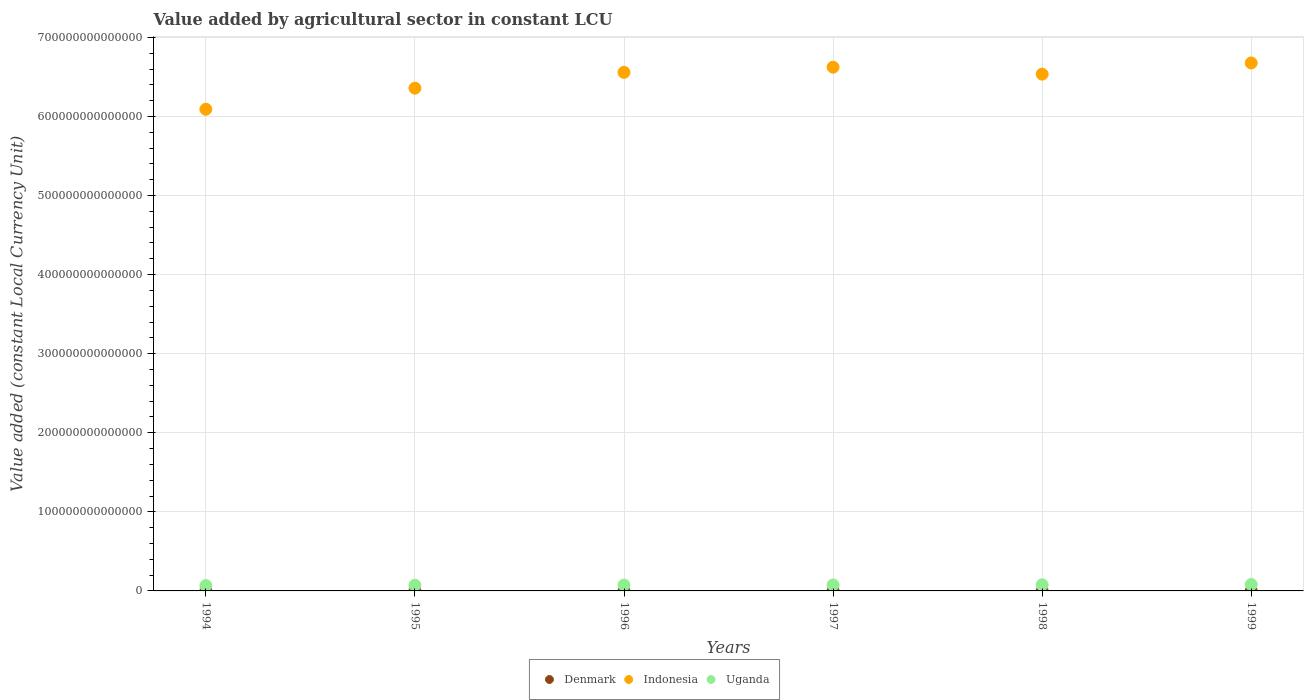How many different coloured dotlines are there?
Keep it short and to the point. 3. Is the number of dotlines equal to the number of legend labels?
Make the answer very short. Yes. What is the value added by agricultural sector in Denmark in 1997?
Give a very brief answer. 2.01e+1. Across all years, what is the maximum value added by agricultural sector in Indonesia?
Your answer should be very brief. 6.68e+14. Across all years, what is the minimum value added by agricultural sector in Uganda?
Provide a succinct answer. 6.78e+12. In which year was the value added by agricultural sector in Denmark maximum?
Offer a terse response. 1998. What is the total value added by agricultural sector in Indonesia in the graph?
Keep it short and to the point. 3.88e+15. What is the difference between the value added by agricultural sector in Uganda in 1997 and that in 1999?
Offer a terse response. -5.82e+11. What is the difference between the value added by agricultural sector in Uganda in 1995 and the value added by agricultural sector in Indonesia in 1999?
Your response must be concise. -6.60e+14. What is the average value added by agricultural sector in Indonesia per year?
Your answer should be very brief. 6.47e+14. In the year 1994, what is the difference between the value added by agricultural sector in Indonesia and value added by agricultural sector in Denmark?
Your response must be concise. 6.09e+14. What is the ratio of the value added by agricultural sector in Uganda in 1996 to that in 1997?
Keep it short and to the point. 0.99. What is the difference between the highest and the second highest value added by agricultural sector in Uganda?
Make the answer very short. 4.48e+11. What is the difference between the highest and the lowest value added by agricultural sector in Denmark?
Offer a very short reply. 2.42e+09. In how many years, is the value added by agricultural sector in Uganda greater than the average value added by agricultural sector in Uganda taken over all years?
Your answer should be very brief. 4. Is the sum of the value added by agricultural sector in Denmark in 1997 and 1998 greater than the maximum value added by agricultural sector in Indonesia across all years?
Keep it short and to the point. No. Is it the case that in every year, the sum of the value added by agricultural sector in Indonesia and value added by agricultural sector in Denmark  is greater than the value added by agricultural sector in Uganda?
Your answer should be compact. Yes. Is the value added by agricultural sector in Denmark strictly greater than the value added by agricultural sector in Uganda over the years?
Your response must be concise. No. Is the value added by agricultural sector in Indonesia strictly less than the value added by agricultural sector in Denmark over the years?
Make the answer very short. No. How many years are there in the graph?
Make the answer very short. 6. What is the difference between two consecutive major ticks on the Y-axis?
Your answer should be compact. 1.00e+14. Are the values on the major ticks of Y-axis written in scientific E-notation?
Your response must be concise. No. Does the graph contain grids?
Offer a very short reply. Yes. What is the title of the graph?
Provide a succinct answer. Value added by agricultural sector in constant LCU. What is the label or title of the Y-axis?
Offer a terse response. Value added (constant Local Currency Unit). What is the Value added (constant Local Currency Unit) in Denmark in 1994?
Offer a terse response. 1.79e+1. What is the Value added (constant Local Currency Unit) of Indonesia in 1994?
Offer a terse response. 6.09e+14. What is the Value added (constant Local Currency Unit) of Uganda in 1994?
Offer a very short reply. 6.78e+12. What is the Value added (constant Local Currency Unit) of Denmark in 1995?
Offer a terse response. 1.89e+1. What is the Value added (constant Local Currency Unit) in Indonesia in 1995?
Provide a short and direct response. 6.36e+14. What is the Value added (constant Local Currency Unit) in Uganda in 1995?
Offer a terse response. 7.18e+12. What is the Value added (constant Local Currency Unit) in Denmark in 1996?
Your response must be concise. 1.94e+1. What is the Value added (constant Local Currency Unit) of Indonesia in 1996?
Your answer should be very brief. 6.56e+14. What is the Value added (constant Local Currency Unit) in Uganda in 1996?
Ensure brevity in your answer.  7.48e+12. What is the Value added (constant Local Currency Unit) of Denmark in 1997?
Your answer should be very brief. 2.01e+1. What is the Value added (constant Local Currency Unit) of Indonesia in 1997?
Provide a short and direct response. 6.62e+14. What is the Value added (constant Local Currency Unit) of Uganda in 1997?
Keep it short and to the point. 7.57e+12. What is the Value added (constant Local Currency Unit) of Denmark in 1998?
Offer a terse response. 2.04e+1. What is the Value added (constant Local Currency Unit) of Indonesia in 1998?
Offer a very short reply. 6.54e+14. What is the Value added (constant Local Currency Unit) of Uganda in 1998?
Your response must be concise. 7.70e+12. What is the Value added (constant Local Currency Unit) in Denmark in 1999?
Give a very brief answer. 2.01e+1. What is the Value added (constant Local Currency Unit) of Indonesia in 1999?
Your answer should be compact. 6.68e+14. What is the Value added (constant Local Currency Unit) in Uganda in 1999?
Offer a very short reply. 8.15e+12. Across all years, what is the maximum Value added (constant Local Currency Unit) of Denmark?
Make the answer very short. 2.04e+1. Across all years, what is the maximum Value added (constant Local Currency Unit) in Indonesia?
Your answer should be compact. 6.68e+14. Across all years, what is the maximum Value added (constant Local Currency Unit) in Uganda?
Offer a very short reply. 8.15e+12. Across all years, what is the minimum Value added (constant Local Currency Unit) of Denmark?
Ensure brevity in your answer.  1.79e+1. Across all years, what is the minimum Value added (constant Local Currency Unit) in Indonesia?
Give a very brief answer. 6.09e+14. Across all years, what is the minimum Value added (constant Local Currency Unit) of Uganda?
Offer a very short reply. 6.78e+12. What is the total Value added (constant Local Currency Unit) in Denmark in the graph?
Your response must be concise. 1.17e+11. What is the total Value added (constant Local Currency Unit) of Indonesia in the graph?
Provide a short and direct response. 3.88e+15. What is the total Value added (constant Local Currency Unit) of Uganda in the graph?
Your answer should be very brief. 4.49e+13. What is the difference between the Value added (constant Local Currency Unit) of Denmark in 1994 and that in 1995?
Your response must be concise. -9.51e+08. What is the difference between the Value added (constant Local Currency Unit) of Indonesia in 1994 and that in 1995?
Give a very brief answer. -2.67e+13. What is the difference between the Value added (constant Local Currency Unit) of Uganda in 1994 and that in 1995?
Keep it short and to the point. -4.00e+11. What is the difference between the Value added (constant Local Currency Unit) in Denmark in 1994 and that in 1996?
Provide a short and direct response. -1.47e+09. What is the difference between the Value added (constant Local Currency Unit) of Indonesia in 1994 and that in 1996?
Your response must be concise. -4.66e+13. What is the difference between the Value added (constant Local Currency Unit) of Uganda in 1994 and that in 1996?
Provide a succinct answer. -7.05e+11. What is the difference between the Value added (constant Local Currency Unit) of Denmark in 1994 and that in 1997?
Offer a terse response. -2.12e+09. What is the difference between the Value added (constant Local Currency Unit) of Indonesia in 1994 and that in 1997?
Give a very brief answer. -5.32e+13. What is the difference between the Value added (constant Local Currency Unit) of Uganda in 1994 and that in 1997?
Provide a succinct answer. -7.87e+11. What is the difference between the Value added (constant Local Currency Unit) of Denmark in 1994 and that in 1998?
Provide a succinct answer. -2.42e+09. What is the difference between the Value added (constant Local Currency Unit) in Indonesia in 1994 and that in 1998?
Provide a short and direct response. -4.44e+13. What is the difference between the Value added (constant Local Currency Unit) of Uganda in 1994 and that in 1998?
Your response must be concise. -9.21e+11. What is the difference between the Value added (constant Local Currency Unit) of Denmark in 1994 and that in 1999?
Offer a terse response. -2.17e+09. What is the difference between the Value added (constant Local Currency Unit) in Indonesia in 1994 and that in 1999?
Make the answer very short. -5.85e+13. What is the difference between the Value added (constant Local Currency Unit) of Uganda in 1994 and that in 1999?
Your response must be concise. -1.37e+12. What is the difference between the Value added (constant Local Currency Unit) of Denmark in 1995 and that in 1996?
Make the answer very short. -5.14e+08. What is the difference between the Value added (constant Local Currency Unit) in Indonesia in 1995 and that in 1996?
Your answer should be compact. -2.00e+13. What is the difference between the Value added (constant Local Currency Unit) in Uganda in 1995 and that in 1996?
Ensure brevity in your answer.  -3.05e+11. What is the difference between the Value added (constant Local Currency Unit) of Denmark in 1995 and that in 1997?
Offer a terse response. -1.17e+09. What is the difference between the Value added (constant Local Currency Unit) of Indonesia in 1995 and that in 1997?
Offer a very short reply. -2.65e+13. What is the difference between the Value added (constant Local Currency Unit) in Uganda in 1995 and that in 1997?
Ensure brevity in your answer.  -3.87e+11. What is the difference between the Value added (constant Local Currency Unit) of Denmark in 1995 and that in 1998?
Offer a terse response. -1.47e+09. What is the difference between the Value added (constant Local Currency Unit) in Indonesia in 1995 and that in 1998?
Keep it short and to the point. -1.77e+13. What is the difference between the Value added (constant Local Currency Unit) in Uganda in 1995 and that in 1998?
Offer a terse response. -5.21e+11. What is the difference between the Value added (constant Local Currency Unit) in Denmark in 1995 and that in 1999?
Make the answer very short. -1.22e+09. What is the difference between the Value added (constant Local Currency Unit) in Indonesia in 1995 and that in 1999?
Offer a very short reply. -3.19e+13. What is the difference between the Value added (constant Local Currency Unit) of Uganda in 1995 and that in 1999?
Your answer should be compact. -9.69e+11. What is the difference between the Value added (constant Local Currency Unit) of Denmark in 1996 and that in 1997?
Keep it short and to the point. -6.52e+08. What is the difference between the Value added (constant Local Currency Unit) in Indonesia in 1996 and that in 1997?
Your answer should be compact. -6.58e+12. What is the difference between the Value added (constant Local Currency Unit) of Uganda in 1996 and that in 1997?
Offer a terse response. -8.15e+1. What is the difference between the Value added (constant Local Currency Unit) of Denmark in 1996 and that in 1998?
Keep it short and to the point. -9.55e+08. What is the difference between the Value added (constant Local Currency Unit) in Indonesia in 1996 and that in 1998?
Offer a very short reply. 2.24e+12. What is the difference between the Value added (constant Local Currency Unit) in Uganda in 1996 and that in 1998?
Make the answer very short. -2.15e+11. What is the difference between the Value added (constant Local Currency Unit) of Denmark in 1996 and that in 1999?
Provide a succinct answer. -7.07e+08. What is the difference between the Value added (constant Local Currency Unit) of Indonesia in 1996 and that in 1999?
Your answer should be compact. -1.19e+13. What is the difference between the Value added (constant Local Currency Unit) of Uganda in 1996 and that in 1999?
Provide a succinct answer. -6.64e+11. What is the difference between the Value added (constant Local Currency Unit) of Denmark in 1997 and that in 1998?
Ensure brevity in your answer.  -3.03e+08. What is the difference between the Value added (constant Local Currency Unit) in Indonesia in 1997 and that in 1998?
Keep it short and to the point. 8.82e+12. What is the difference between the Value added (constant Local Currency Unit) of Uganda in 1997 and that in 1998?
Your answer should be compact. -1.34e+11. What is the difference between the Value added (constant Local Currency Unit) in Denmark in 1997 and that in 1999?
Offer a terse response. -5.50e+07. What is the difference between the Value added (constant Local Currency Unit) in Indonesia in 1997 and that in 1999?
Your answer should be very brief. -5.32e+12. What is the difference between the Value added (constant Local Currency Unit) in Uganda in 1997 and that in 1999?
Keep it short and to the point. -5.82e+11. What is the difference between the Value added (constant Local Currency Unit) of Denmark in 1998 and that in 1999?
Give a very brief answer. 2.48e+08. What is the difference between the Value added (constant Local Currency Unit) of Indonesia in 1998 and that in 1999?
Offer a very short reply. -1.41e+13. What is the difference between the Value added (constant Local Currency Unit) of Uganda in 1998 and that in 1999?
Offer a very short reply. -4.48e+11. What is the difference between the Value added (constant Local Currency Unit) in Denmark in 1994 and the Value added (constant Local Currency Unit) in Indonesia in 1995?
Make the answer very short. -6.36e+14. What is the difference between the Value added (constant Local Currency Unit) in Denmark in 1994 and the Value added (constant Local Currency Unit) in Uganda in 1995?
Keep it short and to the point. -7.16e+12. What is the difference between the Value added (constant Local Currency Unit) in Indonesia in 1994 and the Value added (constant Local Currency Unit) in Uganda in 1995?
Offer a very short reply. 6.02e+14. What is the difference between the Value added (constant Local Currency Unit) of Denmark in 1994 and the Value added (constant Local Currency Unit) of Indonesia in 1996?
Offer a very short reply. -6.56e+14. What is the difference between the Value added (constant Local Currency Unit) in Denmark in 1994 and the Value added (constant Local Currency Unit) in Uganda in 1996?
Your answer should be very brief. -7.47e+12. What is the difference between the Value added (constant Local Currency Unit) of Indonesia in 1994 and the Value added (constant Local Currency Unit) of Uganda in 1996?
Your response must be concise. 6.02e+14. What is the difference between the Value added (constant Local Currency Unit) in Denmark in 1994 and the Value added (constant Local Currency Unit) in Indonesia in 1997?
Your response must be concise. -6.62e+14. What is the difference between the Value added (constant Local Currency Unit) of Denmark in 1994 and the Value added (constant Local Currency Unit) of Uganda in 1997?
Give a very brief answer. -7.55e+12. What is the difference between the Value added (constant Local Currency Unit) of Indonesia in 1994 and the Value added (constant Local Currency Unit) of Uganda in 1997?
Offer a very short reply. 6.02e+14. What is the difference between the Value added (constant Local Currency Unit) in Denmark in 1994 and the Value added (constant Local Currency Unit) in Indonesia in 1998?
Provide a short and direct response. -6.54e+14. What is the difference between the Value added (constant Local Currency Unit) of Denmark in 1994 and the Value added (constant Local Currency Unit) of Uganda in 1998?
Ensure brevity in your answer.  -7.68e+12. What is the difference between the Value added (constant Local Currency Unit) in Indonesia in 1994 and the Value added (constant Local Currency Unit) in Uganda in 1998?
Make the answer very short. 6.01e+14. What is the difference between the Value added (constant Local Currency Unit) of Denmark in 1994 and the Value added (constant Local Currency Unit) of Indonesia in 1999?
Ensure brevity in your answer.  -6.68e+14. What is the difference between the Value added (constant Local Currency Unit) in Denmark in 1994 and the Value added (constant Local Currency Unit) in Uganda in 1999?
Provide a succinct answer. -8.13e+12. What is the difference between the Value added (constant Local Currency Unit) in Indonesia in 1994 and the Value added (constant Local Currency Unit) in Uganda in 1999?
Give a very brief answer. 6.01e+14. What is the difference between the Value added (constant Local Currency Unit) in Denmark in 1995 and the Value added (constant Local Currency Unit) in Indonesia in 1996?
Offer a terse response. -6.56e+14. What is the difference between the Value added (constant Local Currency Unit) in Denmark in 1995 and the Value added (constant Local Currency Unit) in Uganda in 1996?
Offer a terse response. -7.46e+12. What is the difference between the Value added (constant Local Currency Unit) of Indonesia in 1995 and the Value added (constant Local Currency Unit) of Uganda in 1996?
Your answer should be very brief. 6.28e+14. What is the difference between the Value added (constant Local Currency Unit) in Denmark in 1995 and the Value added (constant Local Currency Unit) in Indonesia in 1997?
Ensure brevity in your answer.  -6.62e+14. What is the difference between the Value added (constant Local Currency Unit) of Denmark in 1995 and the Value added (constant Local Currency Unit) of Uganda in 1997?
Ensure brevity in your answer.  -7.55e+12. What is the difference between the Value added (constant Local Currency Unit) in Indonesia in 1995 and the Value added (constant Local Currency Unit) in Uganda in 1997?
Offer a terse response. 6.28e+14. What is the difference between the Value added (constant Local Currency Unit) of Denmark in 1995 and the Value added (constant Local Currency Unit) of Indonesia in 1998?
Ensure brevity in your answer.  -6.53e+14. What is the difference between the Value added (constant Local Currency Unit) in Denmark in 1995 and the Value added (constant Local Currency Unit) in Uganda in 1998?
Your answer should be very brief. -7.68e+12. What is the difference between the Value added (constant Local Currency Unit) in Indonesia in 1995 and the Value added (constant Local Currency Unit) in Uganda in 1998?
Your answer should be compact. 6.28e+14. What is the difference between the Value added (constant Local Currency Unit) of Denmark in 1995 and the Value added (constant Local Currency Unit) of Indonesia in 1999?
Provide a short and direct response. -6.68e+14. What is the difference between the Value added (constant Local Currency Unit) of Denmark in 1995 and the Value added (constant Local Currency Unit) of Uganda in 1999?
Give a very brief answer. -8.13e+12. What is the difference between the Value added (constant Local Currency Unit) of Indonesia in 1995 and the Value added (constant Local Currency Unit) of Uganda in 1999?
Make the answer very short. 6.28e+14. What is the difference between the Value added (constant Local Currency Unit) in Denmark in 1996 and the Value added (constant Local Currency Unit) in Indonesia in 1997?
Provide a succinct answer. -6.62e+14. What is the difference between the Value added (constant Local Currency Unit) of Denmark in 1996 and the Value added (constant Local Currency Unit) of Uganda in 1997?
Your answer should be compact. -7.55e+12. What is the difference between the Value added (constant Local Currency Unit) of Indonesia in 1996 and the Value added (constant Local Currency Unit) of Uganda in 1997?
Provide a succinct answer. 6.48e+14. What is the difference between the Value added (constant Local Currency Unit) in Denmark in 1996 and the Value added (constant Local Currency Unit) in Indonesia in 1998?
Your answer should be very brief. -6.53e+14. What is the difference between the Value added (constant Local Currency Unit) in Denmark in 1996 and the Value added (constant Local Currency Unit) in Uganda in 1998?
Offer a very short reply. -7.68e+12. What is the difference between the Value added (constant Local Currency Unit) in Indonesia in 1996 and the Value added (constant Local Currency Unit) in Uganda in 1998?
Ensure brevity in your answer.  6.48e+14. What is the difference between the Value added (constant Local Currency Unit) in Denmark in 1996 and the Value added (constant Local Currency Unit) in Indonesia in 1999?
Provide a short and direct response. -6.68e+14. What is the difference between the Value added (constant Local Currency Unit) of Denmark in 1996 and the Value added (constant Local Currency Unit) of Uganda in 1999?
Keep it short and to the point. -8.13e+12. What is the difference between the Value added (constant Local Currency Unit) of Indonesia in 1996 and the Value added (constant Local Currency Unit) of Uganda in 1999?
Ensure brevity in your answer.  6.48e+14. What is the difference between the Value added (constant Local Currency Unit) in Denmark in 1997 and the Value added (constant Local Currency Unit) in Indonesia in 1998?
Your answer should be very brief. -6.53e+14. What is the difference between the Value added (constant Local Currency Unit) in Denmark in 1997 and the Value added (constant Local Currency Unit) in Uganda in 1998?
Make the answer very short. -7.68e+12. What is the difference between the Value added (constant Local Currency Unit) in Indonesia in 1997 and the Value added (constant Local Currency Unit) in Uganda in 1998?
Your response must be concise. 6.55e+14. What is the difference between the Value added (constant Local Currency Unit) of Denmark in 1997 and the Value added (constant Local Currency Unit) of Indonesia in 1999?
Offer a terse response. -6.68e+14. What is the difference between the Value added (constant Local Currency Unit) of Denmark in 1997 and the Value added (constant Local Currency Unit) of Uganda in 1999?
Ensure brevity in your answer.  -8.13e+12. What is the difference between the Value added (constant Local Currency Unit) in Indonesia in 1997 and the Value added (constant Local Currency Unit) in Uganda in 1999?
Your response must be concise. 6.54e+14. What is the difference between the Value added (constant Local Currency Unit) of Denmark in 1998 and the Value added (constant Local Currency Unit) of Indonesia in 1999?
Provide a succinct answer. -6.68e+14. What is the difference between the Value added (constant Local Currency Unit) of Denmark in 1998 and the Value added (constant Local Currency Unit) of Uganda in 1999?
Offer a very short reply. -8.13e+12. What is the difference between the Value added (constant Local Currency Unit) in Indonesia in 1998 and the Value added (constant Local Currency Unit) in Uganda in 1999?
Your answer should be compact. 6.45e+14. What is the average Value added (constant Local Currency Unit) in Denmark per year?
Provide a succinct answer. 1.95e+1. What is the average Value added (constant Local Currency Unit) in Indonesia per year?
Offer a terse response. 6.47e+14. What is the average Value added (constant Local Currency Unit) of Uganda per year?
Your response must be concise. 7.48e+12. In the year 1994, what is the difference between the Value added (constant Local Currency Unit) of Denmark and Value added (constant Local Currency Unit) of Indonesia?
Give a very brief answer. -6.09e+14. In the year 1994, what is the difference between the Value added (constant Local Currency Unit) of Denmark and Value added (constant Local Currency Unit) of Uganda?
Ensure brevity in your answer.  -6.76e+12. In the year 1994, what is the difference between the Value added (constant Local Currency Unit) in Indonesia and Value added (constant Local Currency Unit) in Uganda?
Make the answer very short. 6.02e+14. In the year 1995, what is the difference between the Value added (constant Local Currency Unit) of Denmark and Value added (constant Local Currency Unit) of Indonesia?
Your answer should be compact. -6.36e+14. In the year 1995, what is the difference between the Value added (constant Local Currency Unit) of Denmark and Value added (constant Local Currency Unit) of Uganda?
Provide a short and direct response. -7.16e+12. In the year 1995, what is the difference between the Value added (constant Local Currency Unit) of Indonesia and Value added (constant Local Currency Unit) of Uganda?
Keep it short and to the point. 6.29e+14. In the year 1996, what is the difference between the Value added (constant Local Currency Unit) in Denmark and Value added (constant Local Currency Unit) in Indonesia?
Provide a short and direct response. -6.56e+14. In the year 1996, what is the difference between the Value added (constant Local Currency Unit) of Denmark and Value added (constant Local Currency Unit) of Uganda?
Offer a terse response. -7.46e+12. In the year 1996, what is the difference between the Value added (constant Local Currency Unit) in Indonesia and Value added (constant Local Currency Unit) in Uganda?
Provide a short and direct response. 6.48e+14. In the year 1997, what is the difference between the Value added (constant Local Currency Unit) of Denmark and Value added (constant Local Currency Unit) of Indonesia?
Your answer should be compact. -6.62e+14. In the year 1997, what is the difference between the Value added (constant Local Currency Unit) in Denmark and Value added (constant Local Currency Unit) in Uganda?
Make the answer very short. -7.55e+12. In the year 1997, what is the difference between the Value added (constant Local Currency Unit) in Indonesia and Value added (constant Local Currency Unit) in Uganda?
Your answer should be very brief. 6.55e+14. In the year 1998, what is the difference between the Value added (constant Local Currency Unit) of Denmark and Value added (constant Local Currency Unit) of Indonesia?
Provide a succinct answer. -6.53e+14. In the year 1998, what is the difference between the Value added (constant Local Currency Unit) in Denmark and Value added (constant Local Currency Unit) in Uganda?
Give a very brief answer. -7.68e+12. In the year 1998, what is the difference between the Value added (constant Local Currency Unit) of Indonesia and Value added (constant Local Currency Unit) of Uganda?
Your answer should be very brief. 6.46e+14. In the year 1999, what is the difference between the Value added (constant Local Currency Unit) of Denmark and Value added (constant Local Currency Unit) of Indonesia?
Your answer should be compact. -6.68e+14. In the year 1999, what is the difference between the Value added (constant Local Currency Unit) in Denmark and Value added (constant Local Currency Unit) in Uganda?
Make the answer very short. -8.13e+12. In the year 1999, what is the difference between the Value added (constant Local Currency Unit) of Indonesia and Value added (constant Local Currency Unit) of Uganda?
Provide a short and direct response. 6.60e+14. What is the ratio of the Value added (constant Local Currency Unit) in Denmark in 1994 to that in 1995?
Your answer should be compact. 0.95. What is the ratio of the Value added (constant Local Currency Unit) of Indonesia in 1994 to that in 1995?
Keep it short and to the point. 0.96. What is the ratio of the Value added (constant Local Currency Unit) of Uganda in 1994 to that in 1995?
Offer a terse response. 0.94. What is the ratio of the Value added (constant Local Currency Unit) of Denmark in 1994 to that in 1996?
Your answer should be very brief. 0.92. What is the ratio of the Value added (constant Local Currency Unit) in Indonesia in 1994 to that in 1996?
Your response must be concise. 0.93. What is the ratio of the Value added (constant Local Currency Unit) in Uganda in 1994 to that in 1996?
Make the answer very short. 0.91. What is the ratio of the Value added (constant Local Currency Unit) in Denmark in 1994 to that in 1997?
Keep it short and to the point. 0.89. What is the ratio of the Value added (constant Local Currency Unit) in Indonesia in 1994 to that in 1997?
Offer a very short reply. 0.92. What is the ratio of the Value added (constant Local Currency Unit) of Uganda in 1994 to that in 1997?
Give a very brief answer. 0.9. What is the ratio of the Value added (constant Local Currency Unit) of Denmark in 1994 to that in 1998?
Your answer should be compact. 0.88. What is the ratio of the Value added (constant Local Currency Unit) of Indonesia in 1994 to that in 1998?
Ensure brevity in your answer.  0.93. What is the ratio of the Value added (constant Local Currency Unit) in Uganda in 1994 to that in 1998?
Your answer should be compact. 0.88. What is the ratio of the Value added (constant Local Currency Unit) in Denmark in 1994 to that in 1999?
Keep it short and to the point. 0.89. What is the ratio of the Value added (constant Local Currency Unit) of Indonesia in 1994 to that in 1999?
Your response must be concise. 0.91. What is the ratio of the Value added (constant Local Currency Unit) of Uganda in 1994 to that in 1999?
Give a very brief answer. 0.83. What is the ratio of the Value added (constant Local Currency Unit) of Denmark in 1995 to that in 1996?
Ensure brevity in your answer.  0.97. What is the ratio of the Value added (constant Local Currency Unit) in Indonesia in 1995 to that in 1996?
Your response must be concise. 0.97. What is the ratio of the Value added (constant Local Currency Unit) of Uganda in 1995 to that in 1996?
Your answer should be very brief. 0.96. What is the ratio of the Value added (constant Local Currency Unit) in Denmark in 1995 to that in 1997?
Your answer should be compact. 0.94. What is the ratio of the Value added (constant Local Currency Unit) in Indonesia in 1995 to that in 1997?
Your response must be concise. 0.96. What is the ratio of the Value added (constant Local Currency Unit) in Uganda in 1995 to that in 1997?
Keep it short and to the point. 0.95. What is the ratio of the Value added (constant Local Currency Unit) in Denmark in 1995 to that in 1998?
Offer a terse response. 0.93. What is the ratio of the Value added (constant Local Currency Unit) of Indonesia in 1995 to that in 1998?
Your answer should be compact. 0.97. What is the ratio of the Value added (constant Local Currency Unit) in Uganda in 1995 to that in 1998?
Keep it short and to the point. 0.93. What is the ratio of the Value added (constant Local Currency Unit) of Denmark in 1995 to that in 1999?
Provide a succinct answer. 0.94. What is the ratio of the Value added (constant Local Currency Unit) in Indonesia in 1995 to that in 1999?
Ensure brevity in your answer.  0.95. What is the ratio of the Value added (constant Local Currency Unit) of Uganda in 1995 to that in 1999?
Give a very brief answer. 0.88. What is the ratio of the Value added (constant Local Currency Unit) of Denmark in 1996 to that in 1997?
Make the answer very short. 0.97. What is the ratio of the Value added (constant Local Currency Unit) of Uganda in 1996 to that in 1997?
Make the answer very short. 0.99. What is the ratio of the Value added (constant Local Currency Unit) in Denmark in 1996 to that in 1998?
Your answer should be very brief. 0.95. What is the ratio of the Value added (constant Local Currency Unit) of Uganda in 1996 to that in 1998?
Ensure brevity in your answer.  0.97. What is the ratio of the Value added (constant Local Currency Unit) of Denmark in 1996 to that in 1999?
Provide a short and direct response. 0.96. What is the ratio of the Value added (constant Local Currency Unit) of Indonesia in 1996 to that in 1999?
Provide a short and direct response. 0.98. What is the ratio of the Value added (constant Local Currency Unit) of Uganda in 1996 to that in 1999?
Provide a short and direct response. 0.92. What is the ratio of the Value added (constant Local Currency Unit) in Denmark in 1997 to that in 1998?
Give a very brief answer. 0.99. What is the ratio of the Value added (constant Local Currency Unit) in Indonesia in 1997 to that in 1998?
Offer a terse response. 1.01. What is the ratio of the Value added (constant Local Currency Unit) of Uganda in 1997 to that in 1998?
Your answer should be very brief. 0.98. What is the ratio of the Value added (constant Local Currency Unit) of Uganda in 1997 to that in 1999?
Ensure brevity in your answer.  0.93. What is the ratio of the Value added (constant Local Currency Unit) of Denmark in 1998 to that in 1999?
Provide a succinct answer. 1.01. What is the ratio of the Value added (constant Local Currency Unit) of Indonesia in 1998 to that in 1999?
Your answer should be compact. 0.98. What is the ratio of the Value added (constant Local Currency Unit) of Uganda in 1998 to that in 1999?
Ensure brevity in your answer.  0.94. What is the difference between the highest and the second highest Value added (constant Local Currency Unit) of Denmark?
Give a very brief answer. 2.48e+08. What is the difference between the highest and the second highest Value added (constant Local Currency Unit) in Indonesia?
Offer a terse response. 5.32e+12. What is the difference between the highest and the second highest Value added (constant Local Currency Unit) of Uganda?
Offer a very short reply. 4.48e+11. What is the difference between the highest and the lowest Value added (constant Local Currency Unit) in Denmark?
Your answer should be very brief. 2.42e+09. What is the difference between the highest and the lowest Value added (constant Local Currency Unit) of Indonesia?
Your answer should be very brief. 5.85e+13. What is the difference between the highest and the lowest Value added (constant Local Currency Unit) in Uganda?
Make the answer very short. 1.37e+12. 